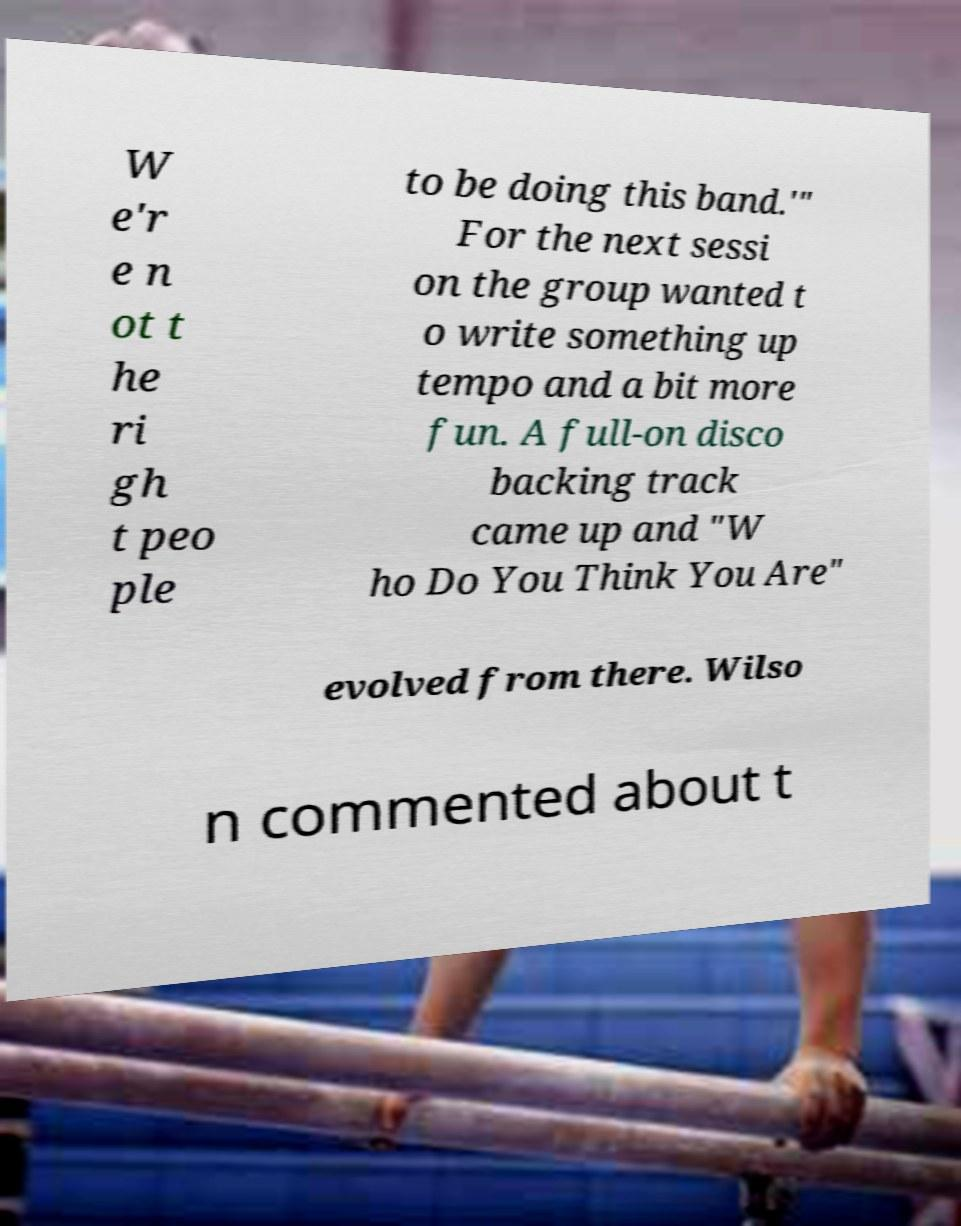For documentation purposes, I need the text within this image transcribed. Could you provide that? W e'r e n ot t he ri gh t peo ple to be doing this band.'" For the next sessi on the group wanted t o write something up tempo and a bit more fun. A full-on disco backing track came up and "W ho Do You Think You Are" evolved from there. Wilso n commented about t 